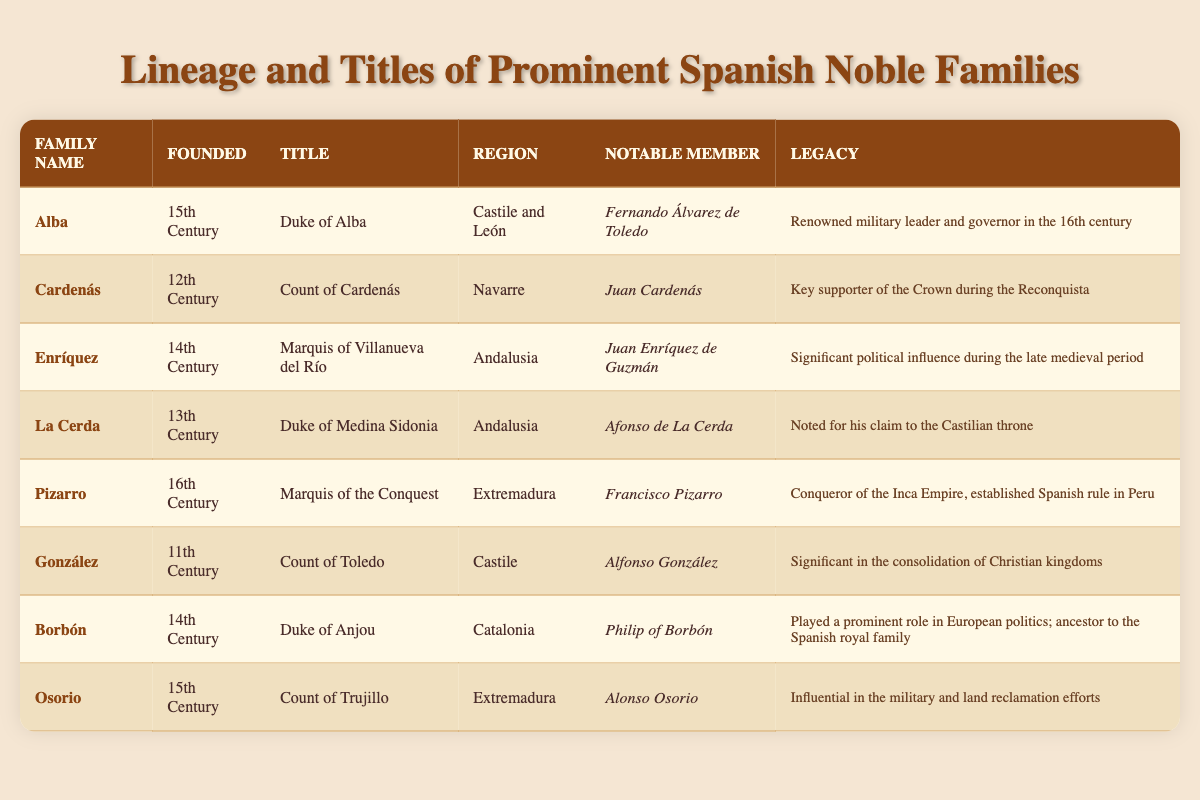What title is held by the family Alba? The title listed next to the family Alba is "Duke of Alba."
Answer: Duke of Alba Which family was established in the 11th century? The family that was founded in the 11th century is the González family.
Answer: González How many families were founded in the 14th century? Two families are noted as being founded in the 14th century: Enríquez and Borbón.
Answer: Two Is Afonso de La Cerda a notable member of the family La Cerda? Yes, Afonso de La Cerda is mentioned as a notable member of the family La Cerda.
Answer: Yes Which family's notable member is known for conquering the Inca Empire? The Pizarro family, with Francisco Pizarro as the notable member, is known for conquering the Inca Empire.
Answer: Pizarro What is the legacy of the González family? The legacy listed for the González family is that they were significant in the consolidation of Christian kingdoms.
Answer: Significant in the consolidation of Christian kingdoms How does the title of the family Borbón compare with that of the family Cardeanas? The Borbón family holds the title "Duke of Anjou" while the Cardenás family holds the title "Count of Cardenás."
Answer: Duke of Anjou; Count of Cardenás Which family has both its founding date and notable member mentioned as part of the military or political influence during their era? The family Enríquez founded in the 14th century, notable member Juan Enríquez de Guzmán, is highlighted for significant political influence.
Answer: Enríquez What region do the families La Cerda and Enríquez both belong to? Both the La Cerda and Enríquez families belong to the region of Andalusia.
Answer: Andalusia How many families have titles relating to "Duke"? Three families hold titles relating to "Duke": Alba, La Cerda, and Borbón.
Answer: Three 